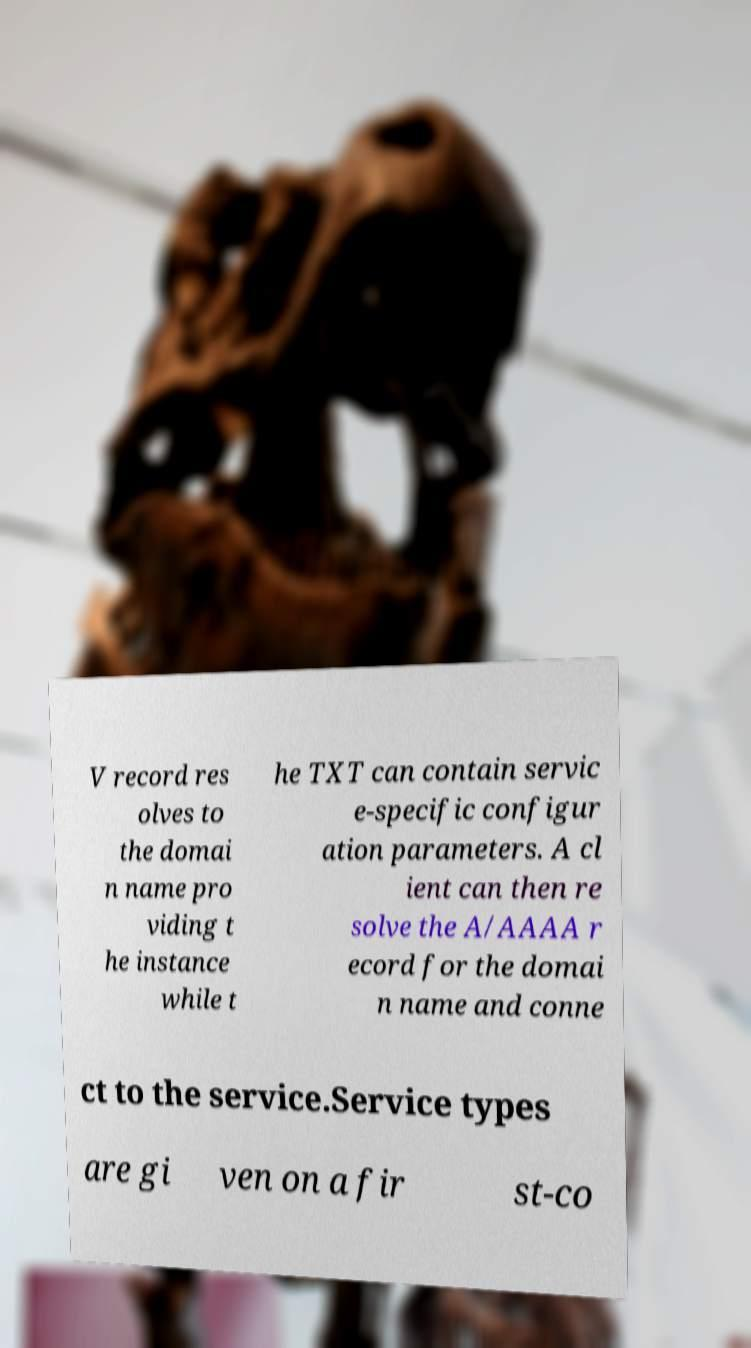For documentation purposes, I need the text within this image transcribed. Could you provide that? V record res olves to the domai n name pro viding t he instance while t he TXT can contain servic e-specific configur ation parameters. A cl ient can then re solve the A/AAAA r ecord for the domai n name and conne ct to the service.Service types are gi ven on a fir st-co 